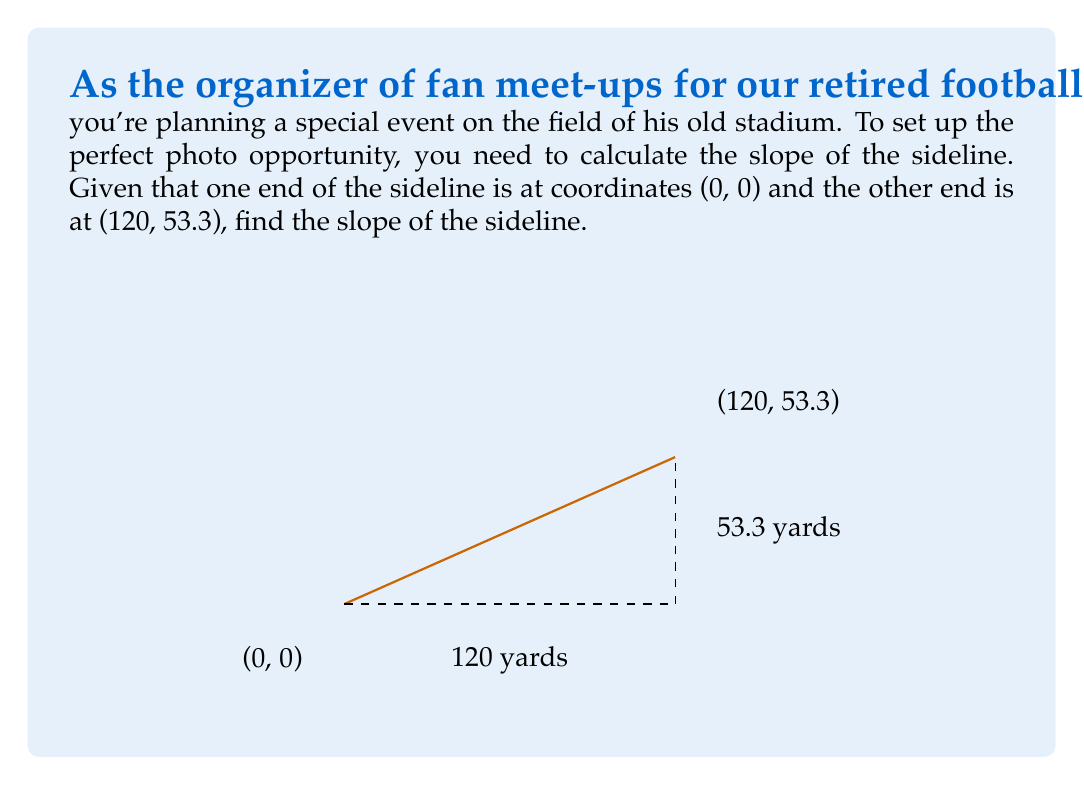Can you answer this question? To find the slope of the sideline, we'll use the slope formula:

$$ m = \frac{y_2 - y_1}{x_2 - x_1} $$

Where $(x_1, y_1)$ is the first point and $(x_2, y_2)$ is the second point.

Given:
- Point 1: $(x_1, y_1) = (0, 0)$
- Point 2: $(x_2, y_2) = (120, 53.3)$

Let's plug these values into the formula:

$$ m = \frac{53.3 - 0}{120 - 0} $$

Simplifying:

$$ m = \frac{53.3}{120} $$

To reduce this fraction, we can divide both the numerator and denominator by their greatest common divisor (GCD). The GCD of 53.3 and 120 is 13.3.

$$ m = \frac{53.3 \div 13.3}{120 \div 13.3} = \frac{4}{9} $$

Therefore, the slope of the sideline is $\frac{4}{9}$.
Answer: $\frac{4}{9}$ 